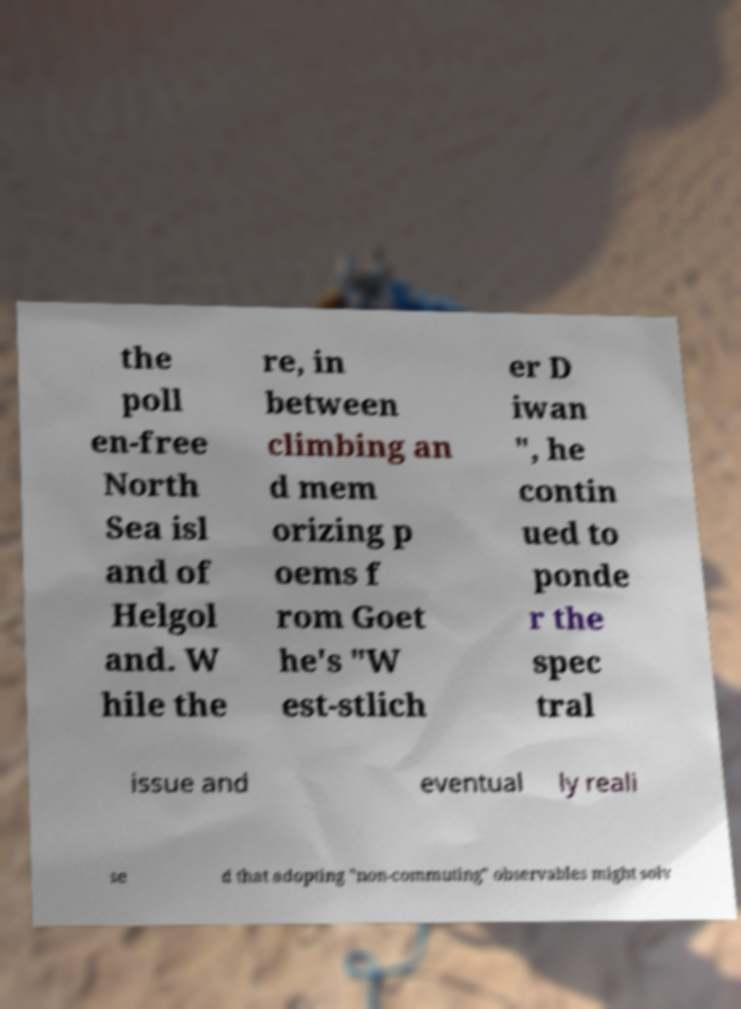Could you assist in decoding the text presented in this image and type it out clearly? the poll en-free North Sea isl and of Helgol and. W hile the re, in between climbing an d mem orizing p oems f rom Goet he's "W est-stlich er D iwan ", he contin ued to ponde r the spec tral issue and eventual ly reali se d that adopting "non-commuting" observables might solv 